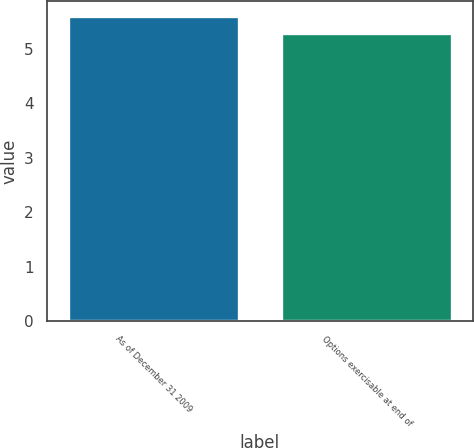Convert chart. <chart><loc_0><loc_0><loc_500><loc_500><bar_chart><fcel>As of December 31 2009<fcel>Options exercisable at end of<nl><fcel>5.6<fcel>5.3<nl></chart> 